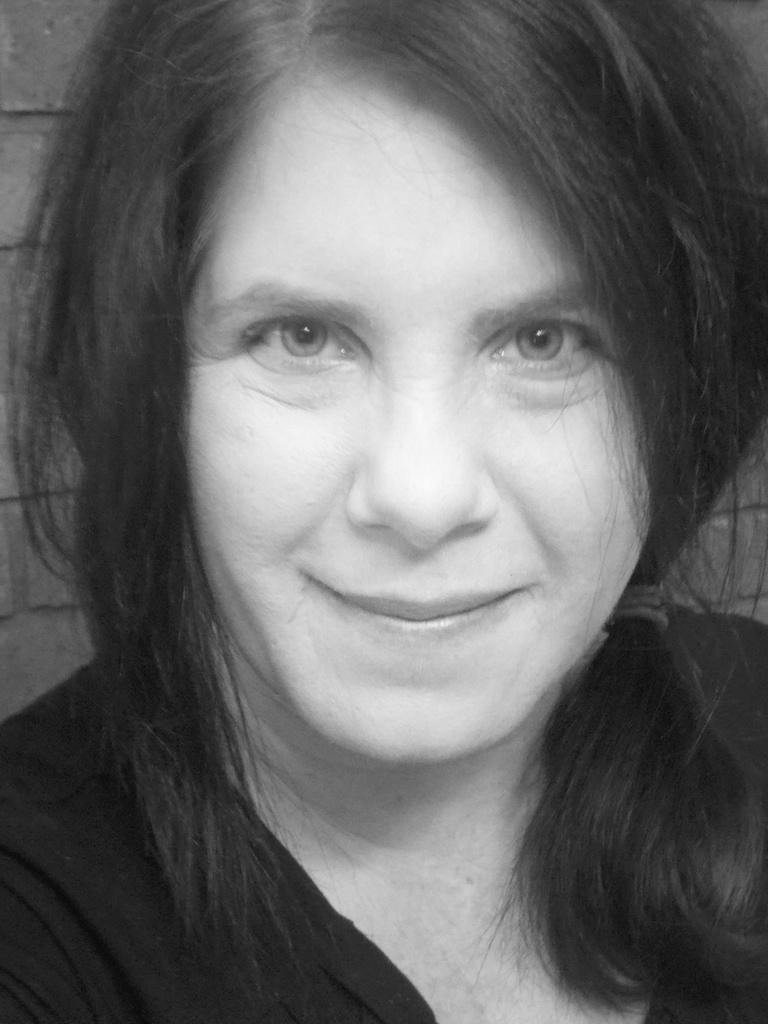What is the color scheme of the image? The image is in black and white. Who is present in the image? There is a woman in the image. What is the woman doing in the image? The woman is smiling. What type of rail can be seen in the image? There is no rail present in the image; it features a woman smiling. How does the woman tie a knot in the image? There is no knot-tying activity depicted in the image; the woman is simply smiling. 